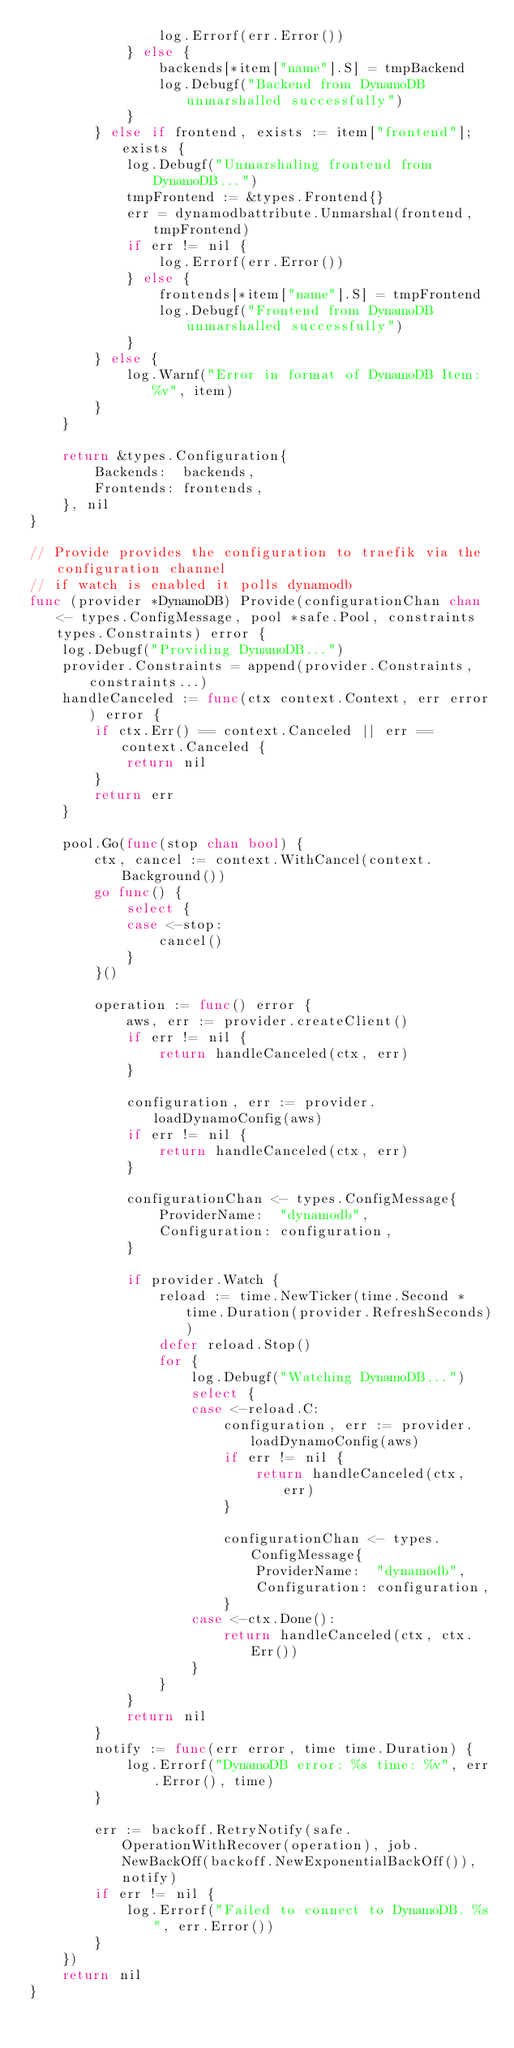Convert code to text. <code><loc_0><loc_0><loc_500><loc_500><_Go_>				log.Errorf(err.Error())
			} else {
				backends[*item["name"].S] = tmpBackend
				log.Debugf("Backend from DynamoDB unmarshalled successfully")
			}
		} else if frontend, exists := item["frontend"]; exists {
			log.Debugf("Unmarshaling frontend from DynamoDB...")
			tmpFrontend := &types.Frontend{}
			err = dynamodbattribute.Unmarshal(frontend, tmpFrontend)
			if err != nil {
				log.Errorf(err.Error())
			} else {
				frontends[*item["name"].S] = tmpFrontend
				log.Debugf("Frontend from DynamoDB unmarshalled successfully")
			}
		} else {
			log.Warnf("Error in format of DynamoDB Item: %v", item)
		}
	}

	return &types.Configuration{
		Backends:  backends,
		Frontends: frontends,
	}, nil
}

// Provide provides the configuration to traefik via the configuration channel
// if watch is enabled it polls dynamodb
func (provider *DynamoDB) Provide(configurationChan chan<- types.ConfigMessage, pool *safe.Pool, constraints types.Constraints) error {
	log.Debugf("Providing DynamoDB...")
	provider.Constraints = append(provider.Constraints, constraints...)
	handleCanceled := func(ctx context.Context, err error) error {
		if ctx.Err() == context.Canceled || err == context.Canceled {
			return nil
		}
		return err
	}

	pool.Go(func(stop chan bool) {
		ctx, cancel := context.WithCancel(context.Background())
		go func() {
			select {
			case <-stop:
				cancel()
			}
		}()

		operation := func() error {
			aws, err := provider.createClient()
			if err != nil {
				return handleCanceled(ctx, err)
			}

			configuration, err := provider.loadDynamoConfig(aws)
			if err != nil {
				return handleCanceled(ctx, err)
			}

			configurationChan <- types.ConfigMessage{
				ProviderName:  "dynamodb",
				Configuration: configuration,
			}

			if provider.Watch {
				reload := time.NewTicker(time.Second * time.Duration(provider.RefreshSeconds))
				defer reload.Stop()
				for {
					log.Debugf("Watching DynamoDB...")
					select {
					case <-reload.C:
						configuration, err := provider.loadDynamoConfig(aws)
						if err != nil {
							return handleCanceled(ctx, err)
						}

						configurationChan <- types.ConfigMessage{
							ProviderName:  "dynamodb",
							Configuration: configuration,
						}
					case <-ctx.Done():
						return handleCanceled(ctx, ctx.Err())
					}
				}
			}
			return nil
		}
		notify := func(err error, time time.Duration) {
			log.Errorf("DynamoDB error: %s time: %v", err.Error(), time)
		}

		err := backoff.RetryNotify(safe.OperationWithRecover(operation), job.NewBackOff(backoff.NewExponentialBackOff()), notify)
		if err != nil {
			log.Errorf("Failed to connect to DynamoDB. %s", err.Error())
		}
	})
	return nil
}
</code> 